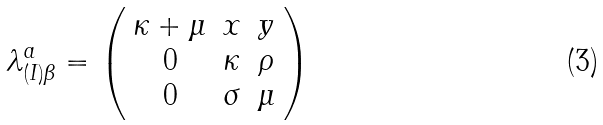Convert formula to latex. <formula><loc_0><loc_0><loc_500><loc_500>\lambda ^ { a } _ { ( I ) \beta } = \left ( \begin{array} { c c c } \kappa + \mu & x & y \\ 0 & \kappa & \rho \\ 0 & \sigma & \mu \end{array} \right )</formula> 